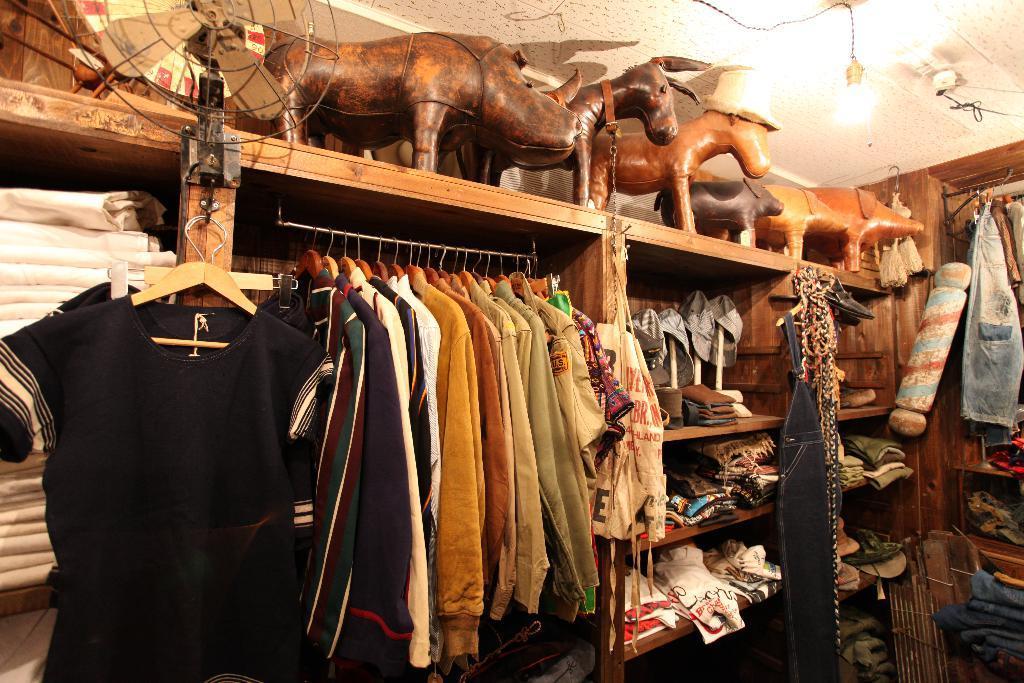Could you give a brief overview of what you see in this image? To the left side of the image there is black t-shirt hanging to the hanger. Beside that there are many shirts hanging to the hangers. Beside that there is a cupboard with many racks. Inside those racks there are many clothes in it. And above that rack that cupboard to the top of the image there are few animal toys. And to the left side of the image to the cupboard there is a table fan. And to the right side of the image there few clothes hanging and few are kept inside the cupboards. 